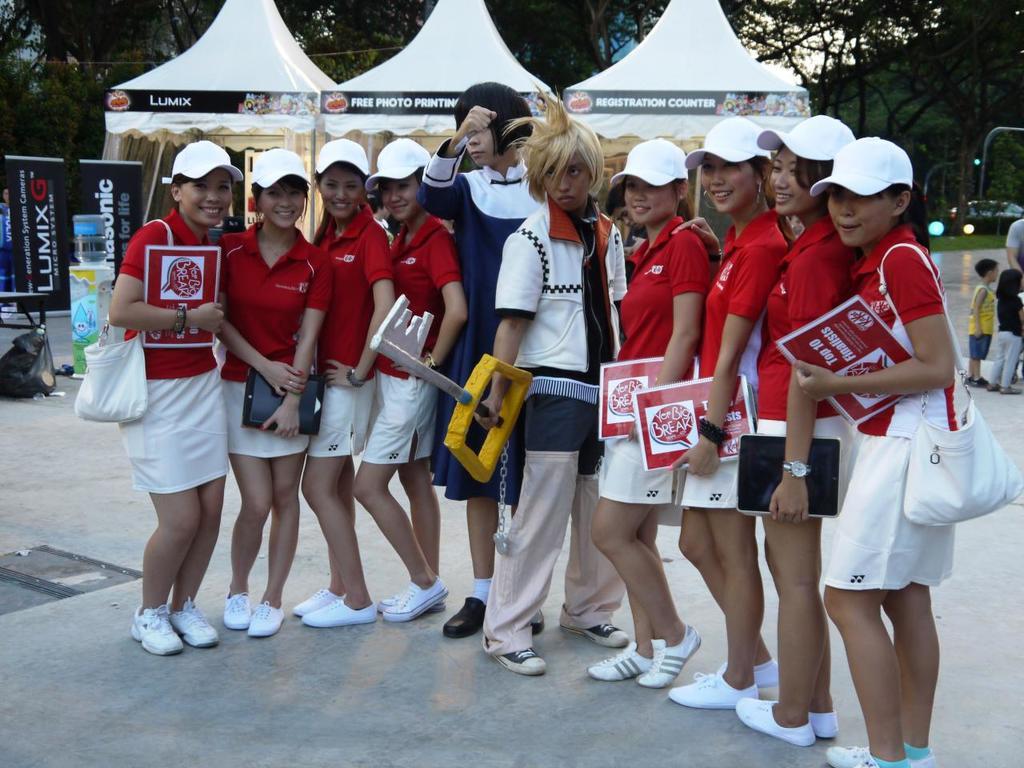What company is offering free photo printing services?
Offer a very short reply. Lumix. 